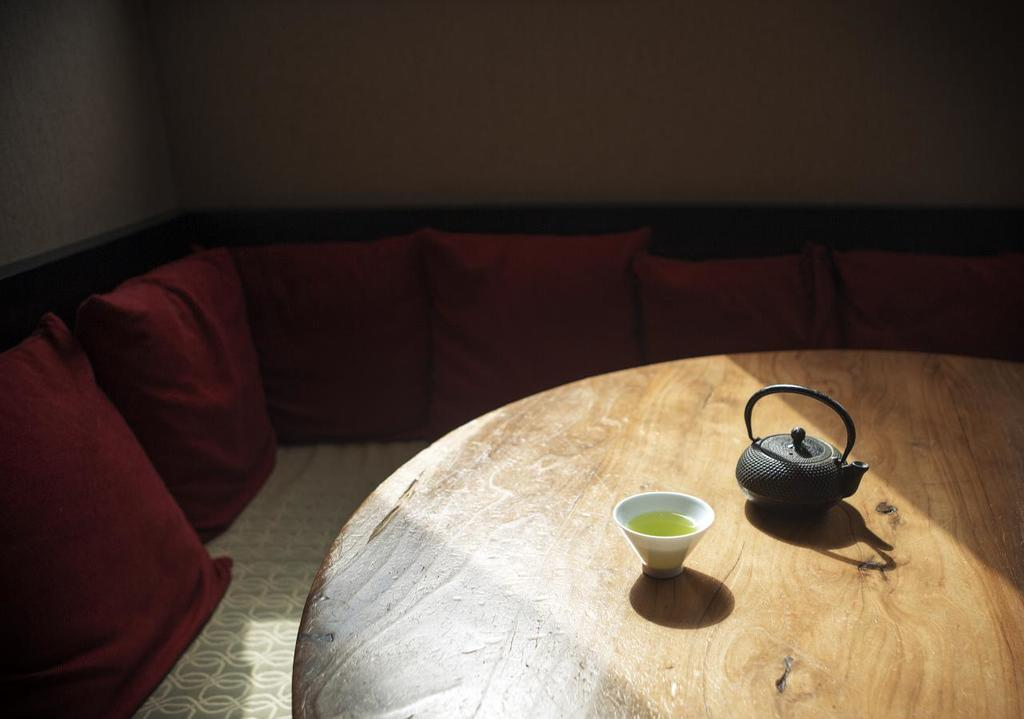What type of table is in the image? There is a wooden table in the image. What is on the table? A cup and a metal flask are on the table. What type of seating is in the image? There is a sofa in the image. What is on the left side of the sofa? Two pillows are on the left side of the sofa. What type of polish is applied to the sofa in the image? There is no mention of polish being applied to the sofa in the image. What type of loss is depicted in the image? There is no loss depicted in the image; it features a wooden table, a cup, a metal flask, a sofa, and two pillows. 